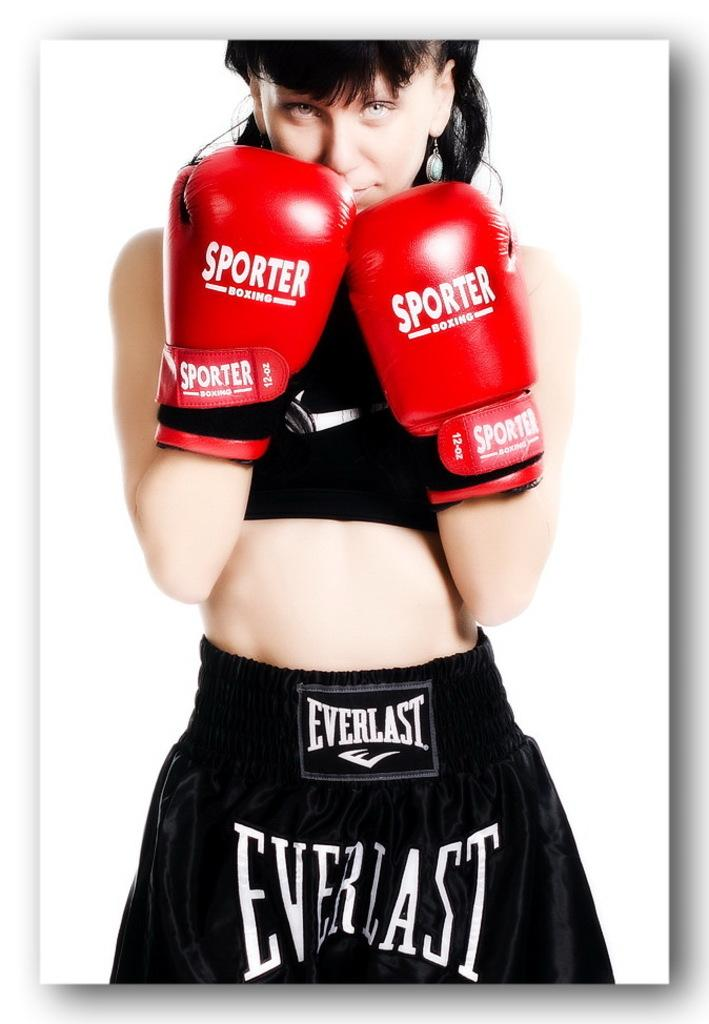Provide a one-sentence caption for the provided image. female boxer wearing everlast trunks and red sporter boxing gloves. 